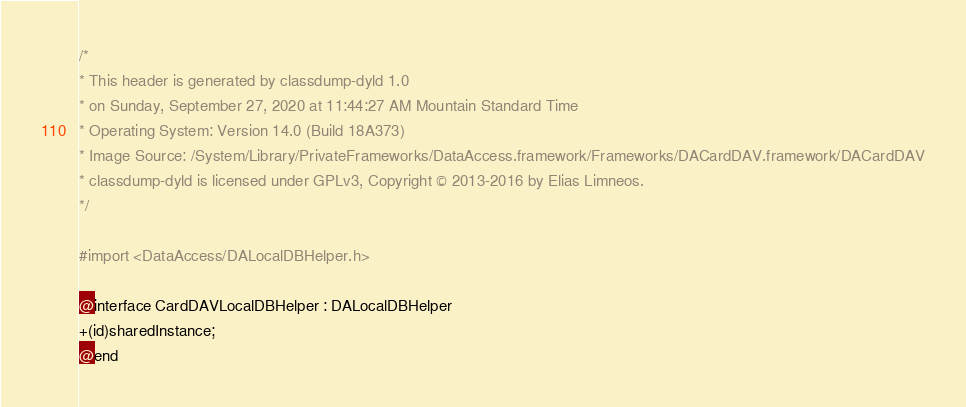Convert code to text. <code><loc_0><loc_0><loc_500><loc_500><_C_>/*
* This header is generated by classdump-dyld 1.0
* on Sunday, September 27, 2020 at 11:44:27 AM Mountain Standard Time
* Operating System: Version 14.0 (Build 18A373)
* Image Source: /System/Library/PrivateFrameworks/DataAccess.framework/Frameworks/DACardDAV.framework/DACardDAV
* classdump-dyld is licensed under GPLv3, Copyright © 2013-2016 by Elias Limneos.
*/

#import <DataAccess/DALocalDBHelper.h>

@interface CardDAVLocalDBHelper : DALocalDBHelper
+(id)sharedInstance;
@end

</code> 